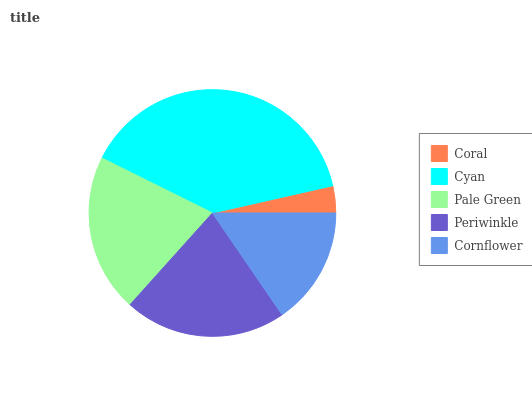Is Coral the minimum?
Answer yes or no. Yes. Is Cyan the maximum?
Answer yes or no. Yes. Is Pale Green the minimum?
Answer yes or no. No. Is Pale Green the maximum?
Answer yes or no. No. Is Cyan greater than Pale Green?
Answer yes or no. Yes. Is Pale Green less than Cyan?
Answer yes or no. Yes. Is Pale Green greater than Cyan?
Answer yes or no. No. Is Cyan less than Pale Green?
Answer yes or no. No. Is Pale Green the high median?
Answer yes or no. Yes. Is Pale Green the low median?
Answer yes or no. Yes. Is Periwinkle the high median?
Answer yes or no. No. Is Cornflower the low median?
Answer yes or no. No. 